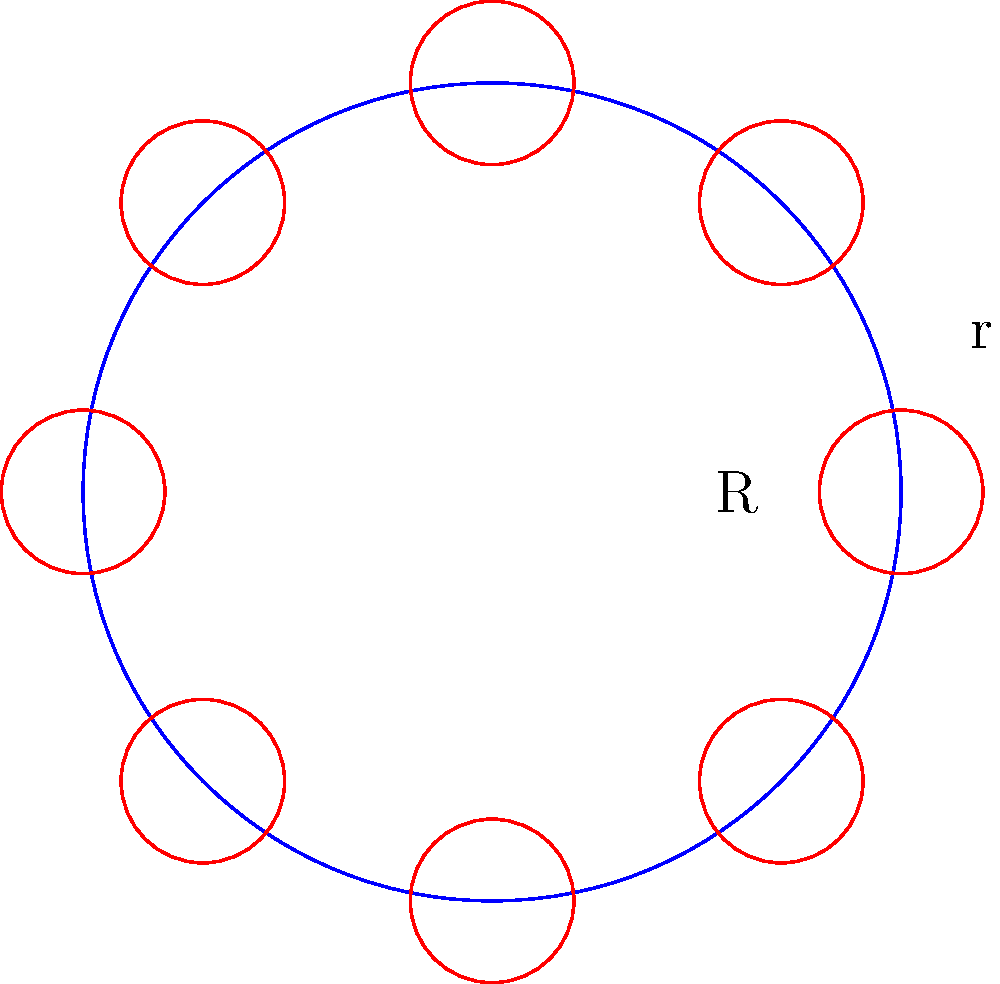As an interior decorator planning a circular buffet table for an event, you need to determine the radius of the table to comfortably accommodate 8 guests. Each guest requires a plate with a radius of 1 foot, and there should be no overlap between plates. What is the minimum radius (R) of the circular buffet table needed to accommodate all guests? To solve this problem, we'll follow these steps:

1. Visualize the arrangement: The plates will be placed around the edge of the circular table, forming a regular octagon.

2. Calculate the central angle: With 8 guests, the central angle between each plate is:
   $$\theta = \frac{360°}{8} = 45°$$

3. Use the law of cosines: In the triangle formed by the center of the table and the centers of two adjacent plates, we have:
   $$R^2 = R^2 + R^2 - 2R^2 \cos(45°)$$
   where $R$ is the radius of the table and $r$ is the radius of each plate.

4. Simplify:
   $$2R^2(1 - \cos(45°)) = (2r)^2$$

5. Solve for $R$:
   $$R^2 = \frac{4r^2}{2(1 - \cos(45°))} = \frac{2r^2}{1 - \cos(45°)}$$
   $$R = \frac{r\sqrt{2}}{\sqrt{1 - \cos(45°)}}$$

6. Calculate the value:
   $$R = \frac{1 \cdot \sqrt{2}}{\sqrt{1 - \cos(45°)}} \approx 2.613\text{ feet}$$

7. Round up to ensure no overlap:
   $R = 2.62\text{ feet}$ (rounded to two decimal places)
Answer: 2.62 feet 